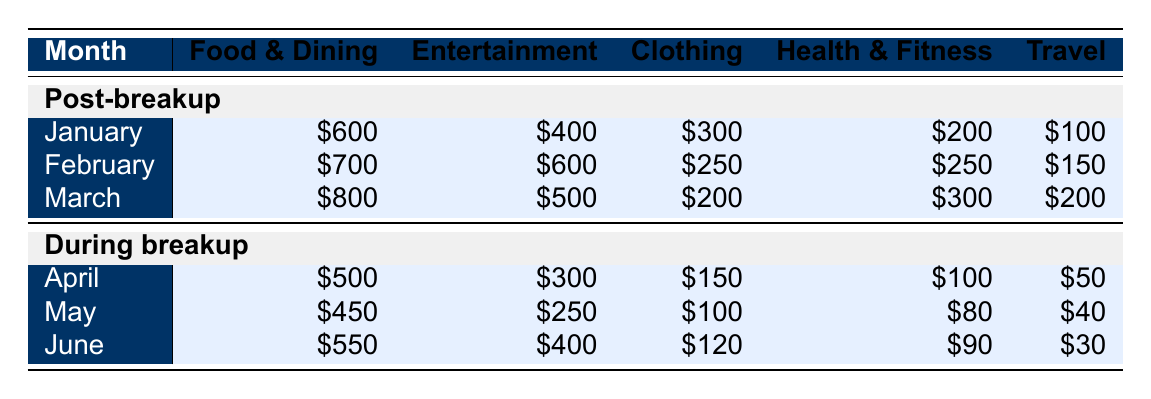What was the total spending on food and dining during the breakup? To find the total spending on food and dining during the breakup, we add the values for April, May, and June: 500 + 450 + 550 = 1500.
Answer: 1500 Which month saw the highest spending on entertainment during the post-breakup period? In the post-breakup period, the entertainment spending amounts were: January 400, February 600, and March 500. The highest value among these is 600 in February.
Answer: February Was the spending on clothing higher during the breakup compared to any post-breakup month? In the breakup months, clothing spending was: April 150, May 100, June 120. In the post-breakup months, it was: January 300, February 250, March 200. Since all post-breakup values are higher than the breakup values, the answer is yes.
Answer: Yes What is the average monthly spending on travel during the breakup phase? The travel spending during the breakup is: April 50, May 40, and June 30. The average is calculated as (50 + 40 + 30) / 3 = 120 / 3 = 40.
Answer: 40 Which category experienced the largest increase in spending from January to March post-breakup? The spending in each category post-breakup is: January (food 600, entertainment 400, clothing 300, health 200, travel 100), February (food 700, entertainment 600, clothing 250, health 250, travel 150), March (food 800, entertainment 500, clothing 200, health 300, travel 200). The largest increase was in food: 700 - 600 = 100 from January to February and 800 - 700 = 100 from February to March, making it a tie.
Answer: Food and Dining (tie) What was the total spent on health and fitness during the entire period analyzed? Adding the health and fitness spending from all months: January 200, February 250, March 300, April 100, May 80, June 90 gives: 200 + 250 + 300 + 100 + 80 + 90 = 1020.
Answer: 1020 Which month had the lowest overall spending, and what was that total? The monthly totals for April (1,000), May (920), June (1,190), January (1,600), February (1,850), March (2,100) indicate May had the lowest total spending of 920.
Answer: May, 920 Did the total spending rise or fall from the month of April to June during the breakup? The total in April was 1,000, in May was 920 (a fall), and in June was 1,190 (a rise). Therefore, from April to July it fell, and then rose, so overall it had fluctuations.
Answer: Fall then rise 